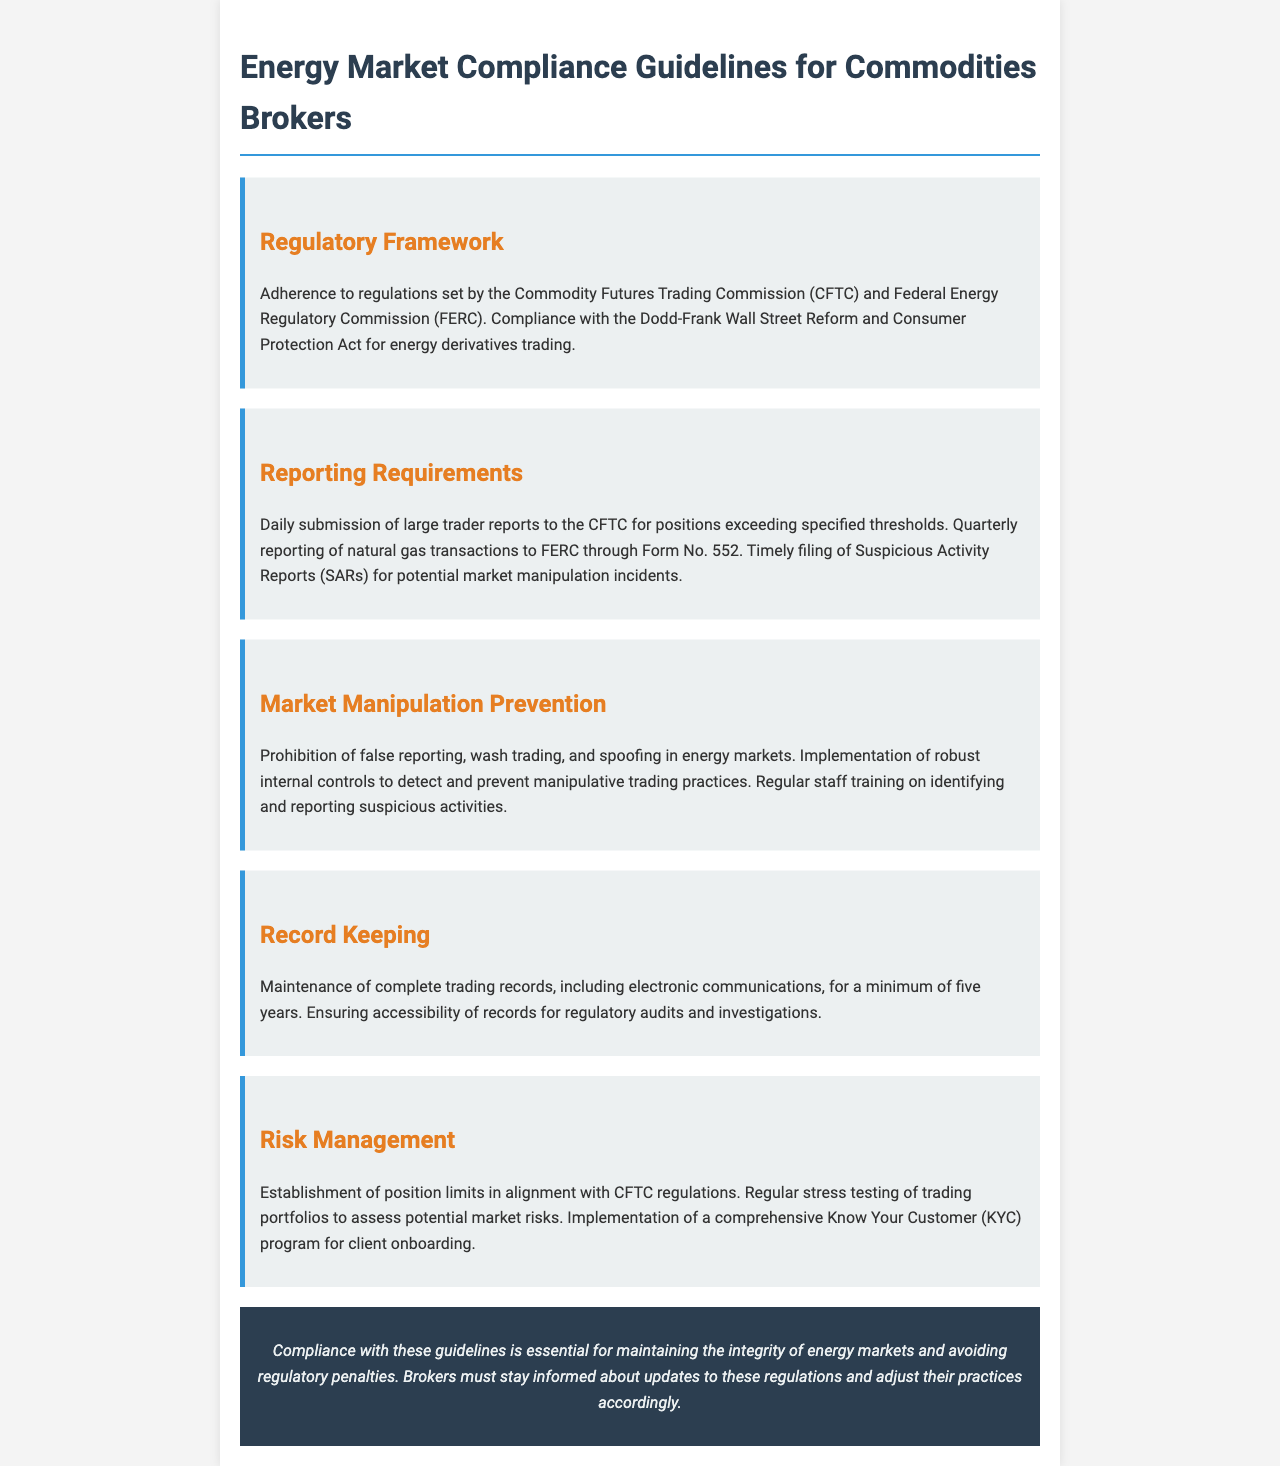what is the regulatory authority mentioned for energy derivatives trading? The document specifies the Commodity Futures Trading Commission (CFTC) and Federal Energy Regulatory Commission (FERC) as the regulatory authorities.
Answer: CFTC and FERC what is required to be submitted daily to the CFTC? The document states that large trader reports for positions exceeding specified thresholds must be submitted daily.
Answer: large trader reports what form is used for quarterly reporting of natural gas transactions? The document mentions Form No. 552 for quarterly reporting of natural gas transactions to FERC.
Answer: Form No. 552 what practices are prohibited to prevent market manipulation? The document lists false reporting, wash trading, and spoofing as prohibited practices in energy markets.
Answer: false reporting, wash trading, and spoofing how long must trading records be maintained? The document specifies that trading records must be maintained for a minimum of five years.
Answer: five years what is the purpose of implementing a comprehensive KYC program? The document states that a comprehensive Know Your Customer (KYC) program is for client onboarding.
Answer: client onboarding what kind of training is emphasized for staff? The document emphasizes regular staff training on identifying and reporting suspicious activities.
Answer: identifying and reporting suspicious activities which act must be complied with for energy derivatives trading? The document mentions the Dodd-Frank Wall Street Reform and Consumer Protection Act as a requirement.
Answer: Dodd-Frank Act what is the consequence of not complying with the guidelines? The document states that non-compliance could lead to regulatory penalties.
Answer: regulatory penalties 